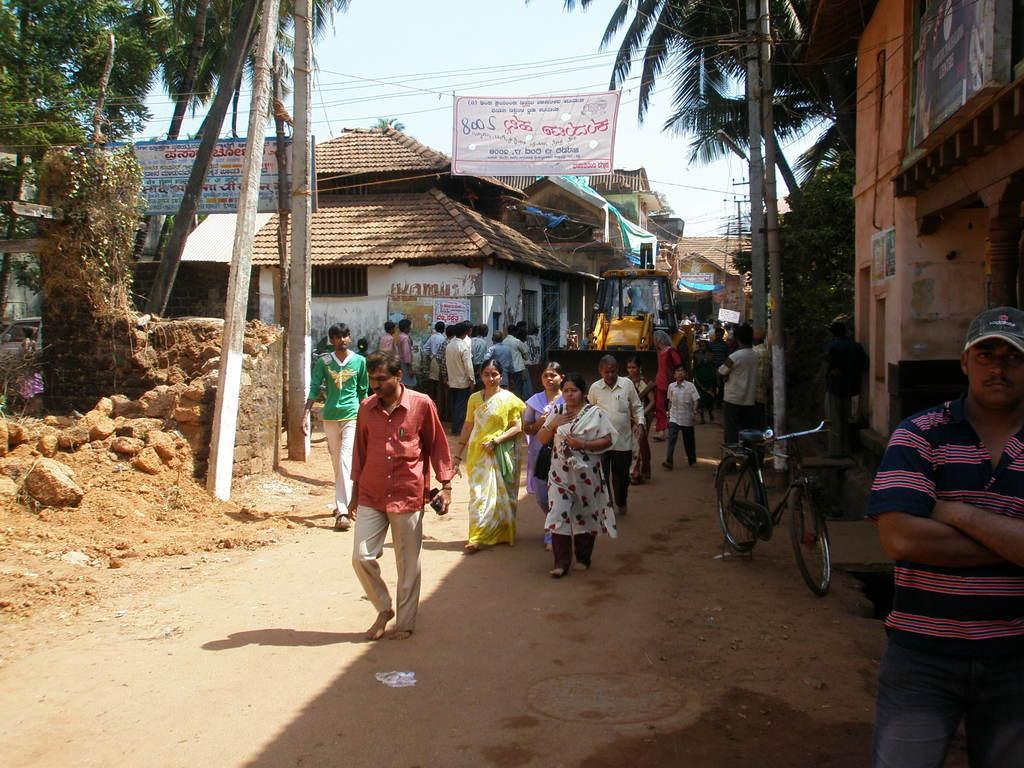How would you summarize this image in a sentence or two? In this picture there are buildings and trees and there are poles and there is a vehicle. In the foreground there are group of people walking and there is a bicycle. At the top there is sky and there are wires and there is a banner and there is text on the banner. At the bottom there is a road. 